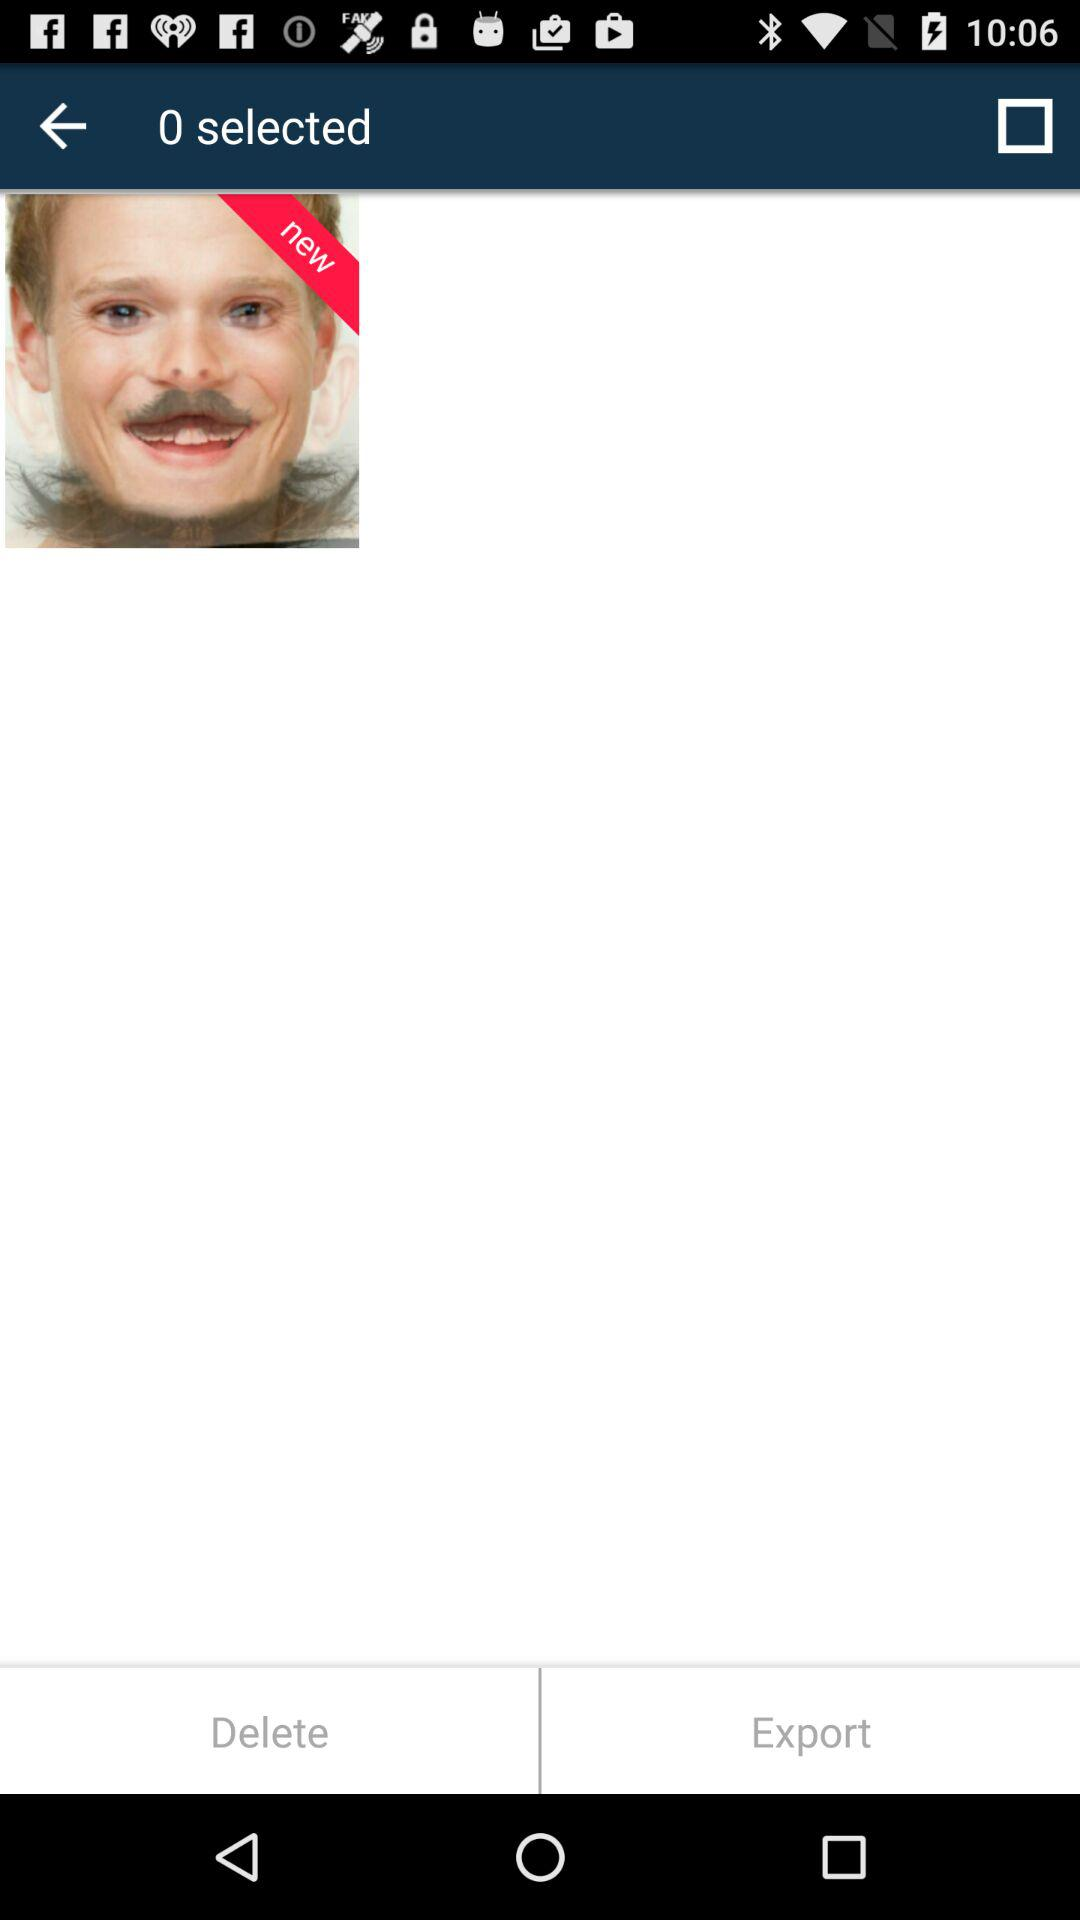How many items are selected? There are 0 selected items. 